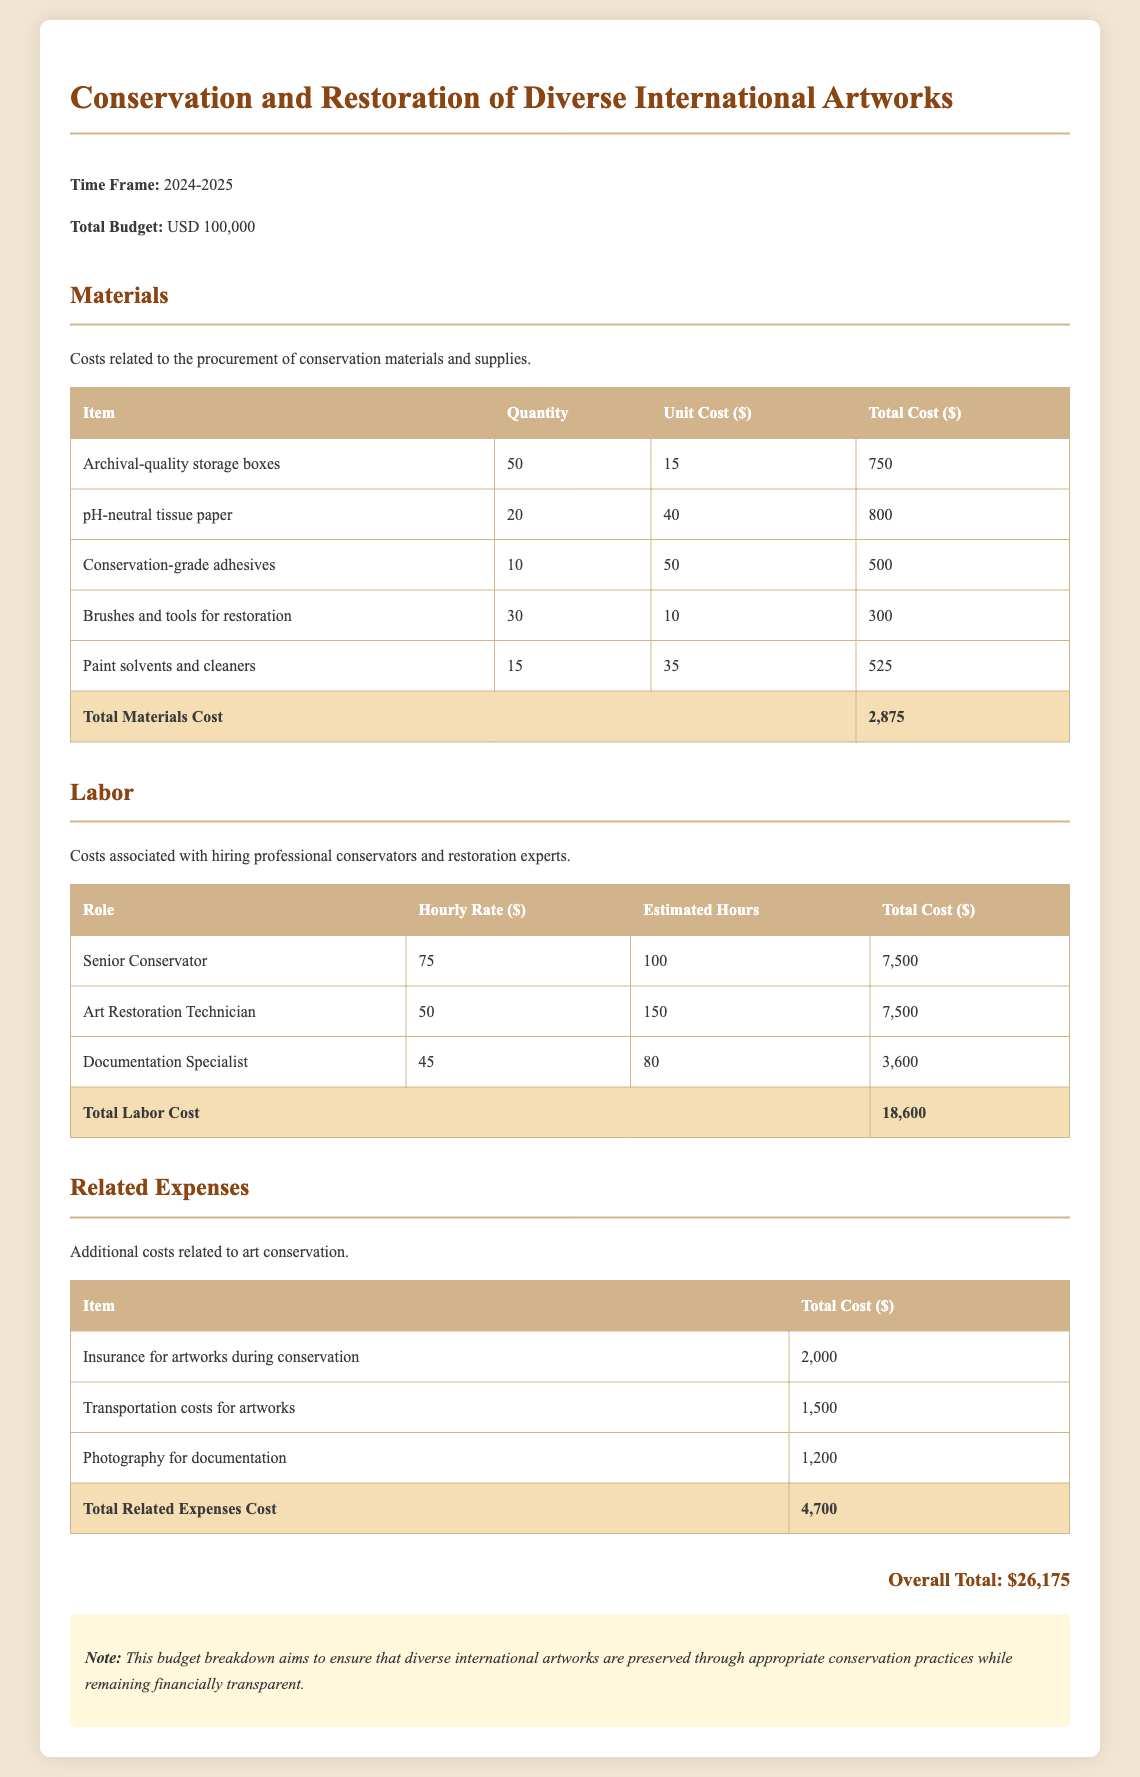what is the total budget for the conservation project? The total budget is directly stated in the document as USD 100,000.
Answer: USD 100,000 what is the total cost for materials? The total cost for materials is calculated by summing all the item costs listed under materials, which is $2,875.
Answer: $2,875 how many archival-quality storage boxes are planned for purchase? The document specifies that 50 archival-quality storage boxes will be purchased.
Answer: 50 what role has an hourly rate of 75 dollars? The role of Senior Conservator has an hourly rate of 75 dollars as mentioned in the labor section.
Answer: Senior Conservator how much is earmarked for insurance for artworks during conservation? The document states that the cost earmarked for insurance during conservation is $2,000.
Answer: $2,000 what is the estimated total labor cost? The estimated total labor cost is the sum of individual labor costs listed in the labor section, which amounts to $18,600.
Answer: $18,600 what is the total cost for transportation of artworks? The document states that the total cost for transportation of artworks is $1,500.
Answer: $1,500 what is the timeframe for the conservation and restoration project? The timeframe for the project is directly mentioned as spanning from 2024 to 2025.
Answer: 2024-2025 what is included in the notes section of the document? The notes section mentions that the budget breakdown aims to ensure the preservation of diverse international artworks while remaining financially transparent.
Answer: Financially transparent 